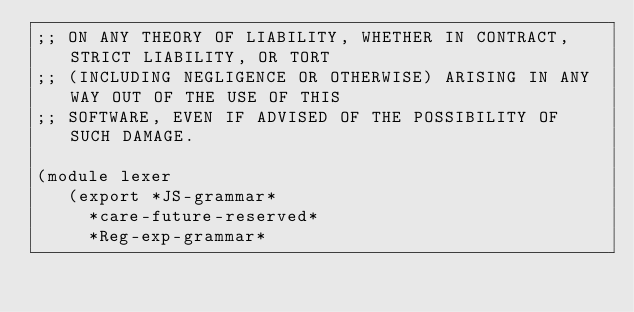<code> <loc_0><loc_0><loc_500><loc_500><_Scheme_>;; ON ANY THEORY OF LIABILITY, WHETHER IN CONTRACT, STRICT LIABILITY, OR TORT
;; (INCLUDING NEGLIGENCE OR OTHERWISE) ARISING IN ANY WAY OUT OF THE USE OF THIS
;; SOFTWARE, EVEN IF ADVISED OF THE POSSIBILITY OF SUCH DAMAGE.

(module lexer
   (export *JS-grammar*
	   *care-future-reserved*
	   *Reg-exp-grammar*</code> 